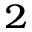<formula> <loc_0><loc_0><loc_500><loc_500>^ { 2 }</formula> 